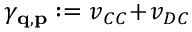Convert formula to latex. <formula><loc_0><loc_0><loc_500><loc_500>\gamma _ { q , p } \colon = v _ { C C } \, + \, v _ { D C }</formula> 